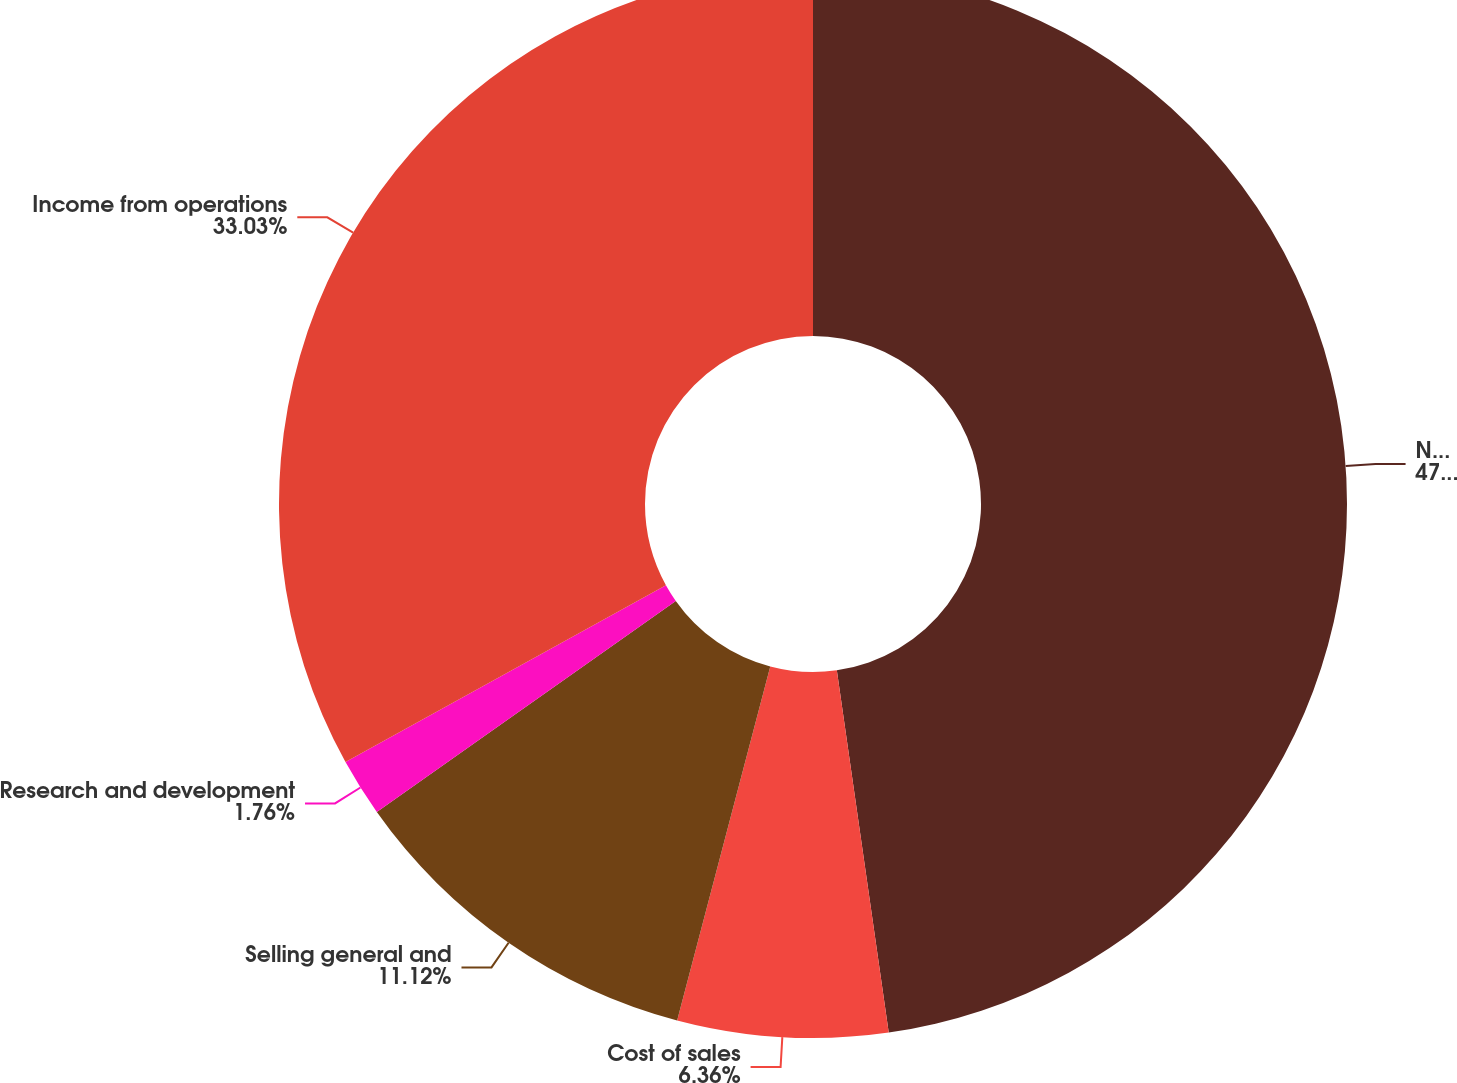Convert chart. <chart><loc_0><loc_0><loc_500><loc_500><pie_chart><fcel>Net sales<fcel>Cost of sales<fcel>Selling general and<fcel>Research and development<fcel>Income from operations<nl><fcel>47.74%<fcel>6.36%<fcel>11.12%<fcel>1.76%<fcel>33.03%<nl></chart> 